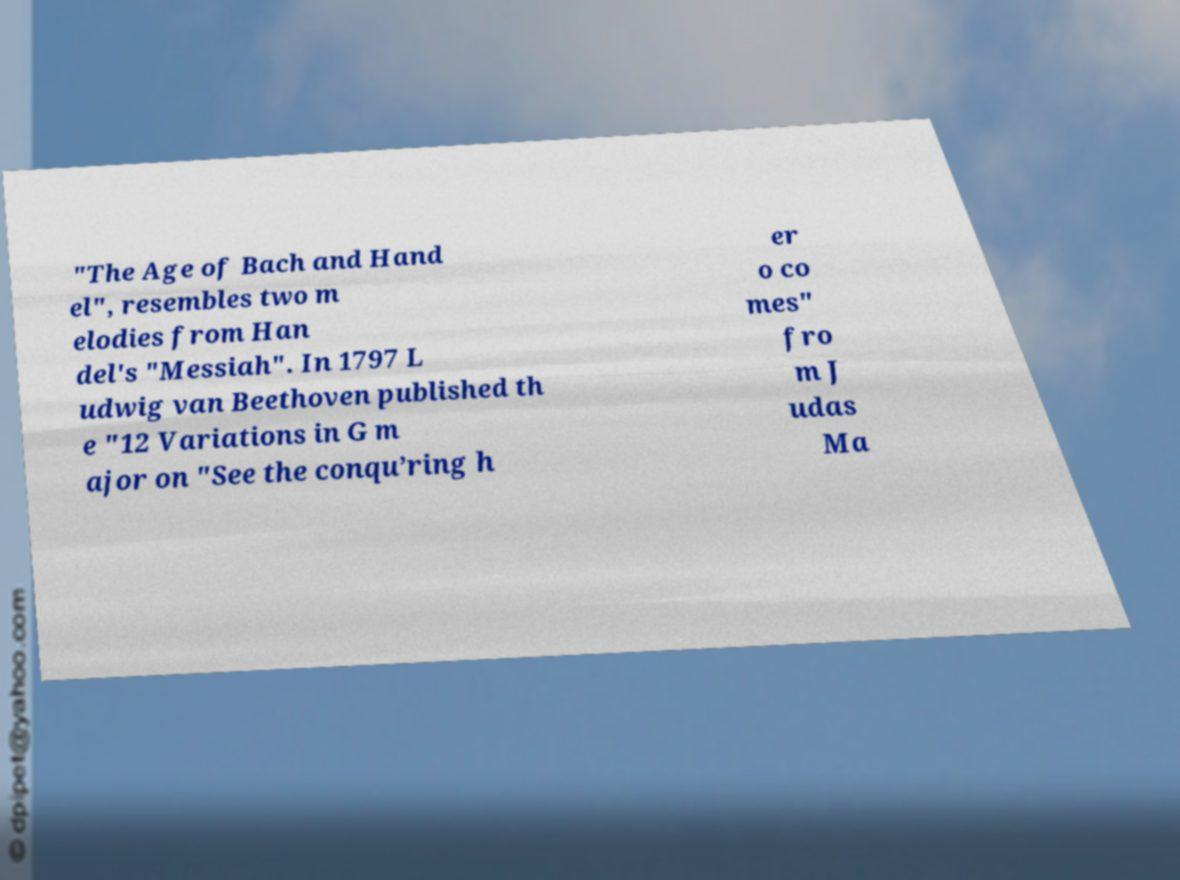Can you accurately transcribe the text from the provided image for me? "The Age of Bach and Hand el", resembles two m elodies from Han del's "Messiah". In 1797 L udwig van Beethoven published th e "12 Variations in G m ajor on "See the conqu’ring h er o co mes" fro m J udas Ma 